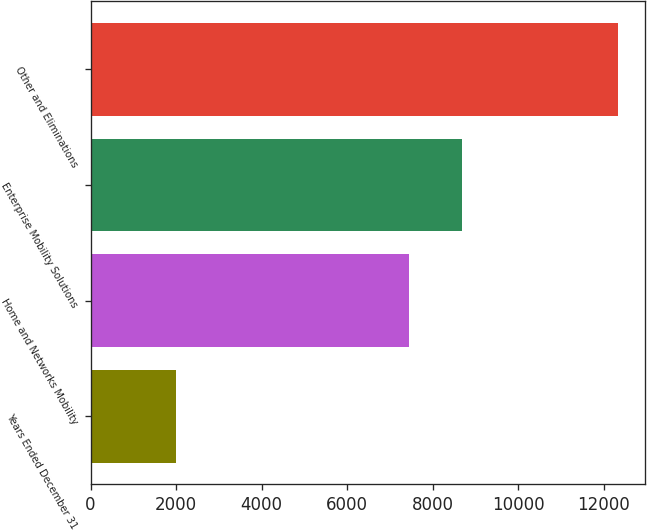Convert chart. <chart><loc_0><loc_0><loc_500><loc_500><bar_chart><fcel>Years Ended December 31<fcel>Home and Networks Mobility<fcel>Enterprise Mobility Solutions<fcel>Other and Eliminations<nl><fcel>2007<fcel>7451<fcel>8694<fcel>12342<nl></chart> 